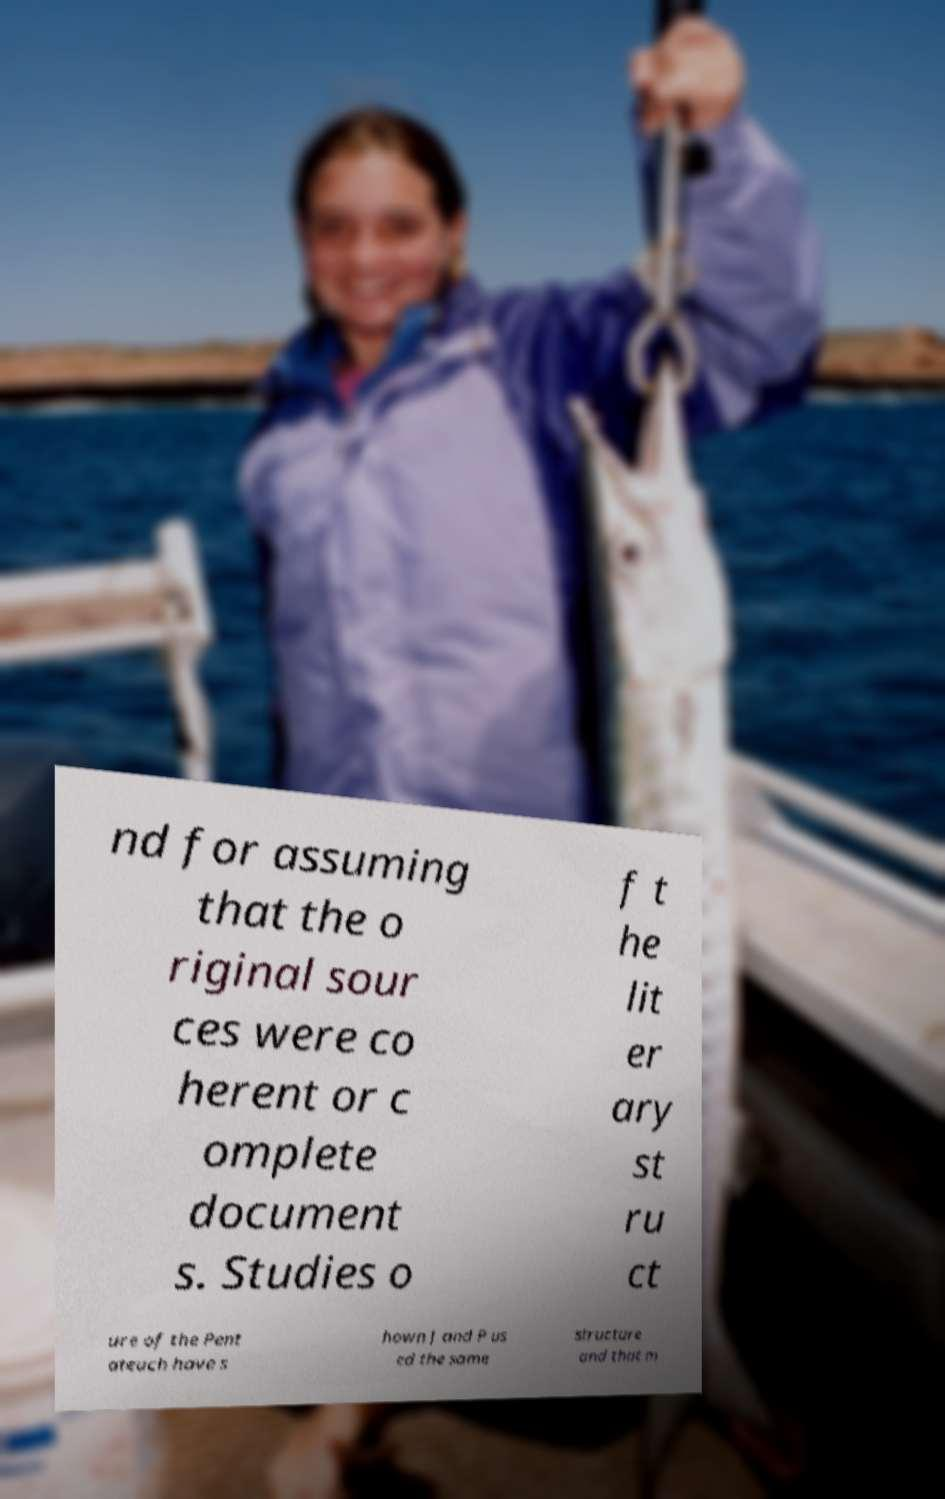I need the written content from this picture converted into text. Can you do that? nd for assuming that the o riginal sour ces were co herent or c omplete document s. Studies o f t he lit er ary st ru ct ure of the Pent ateuch have s hown J and P us ed the same structure and that m 